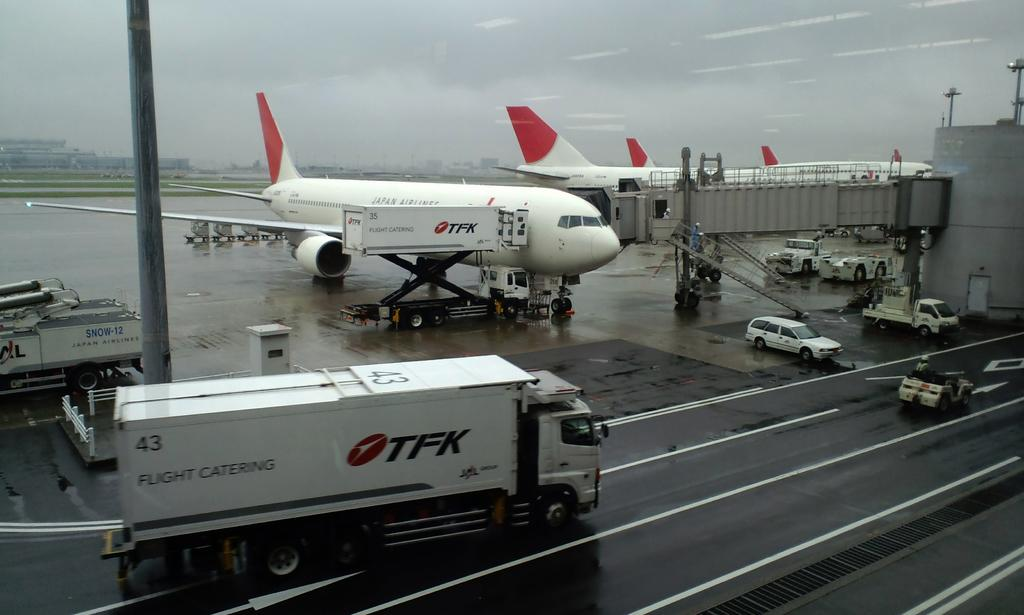<image>
Render a clear and concise summary of the photo. A TFK truck is parked in front of multiple TFK planes at an airport. 